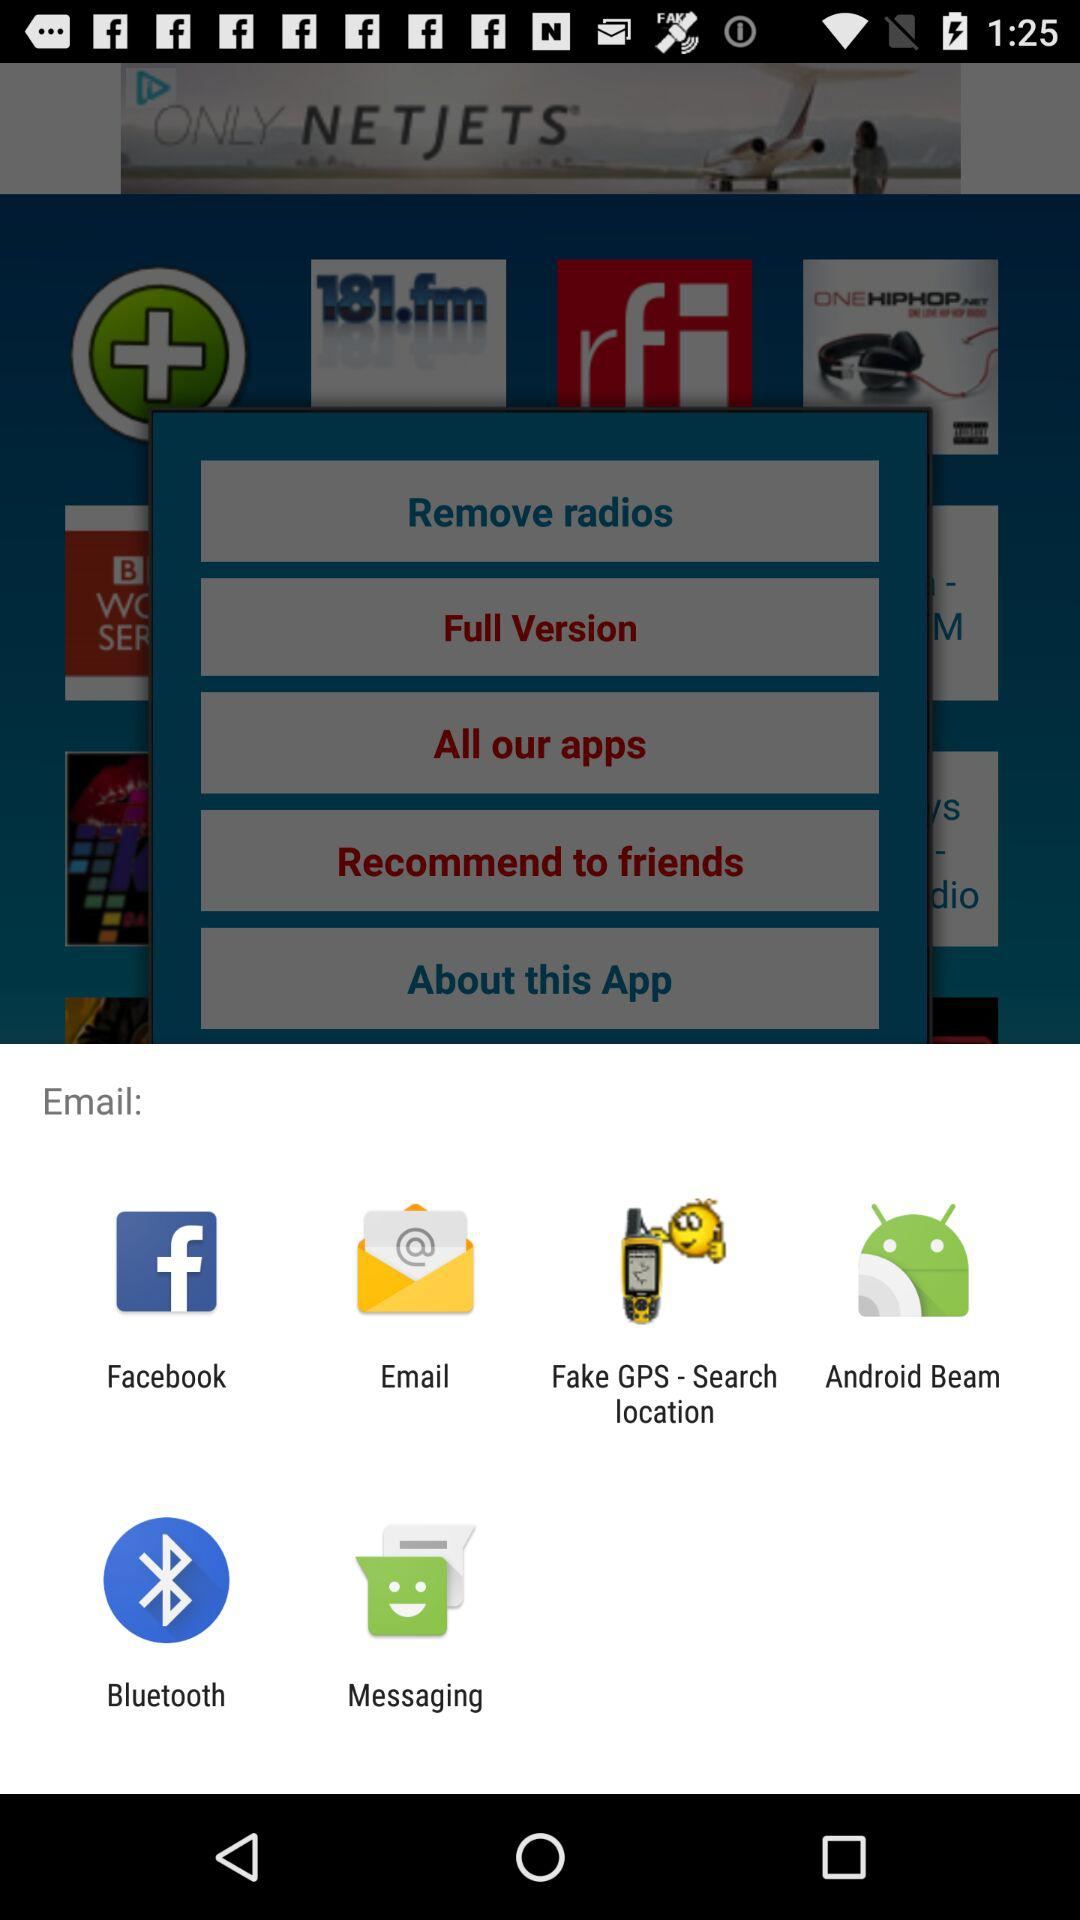What are the different applications through which we can email? The applications are "Facebook", "Fake GPS - Search location", "Android Beam", "Bluetooth" and "Messaging". 